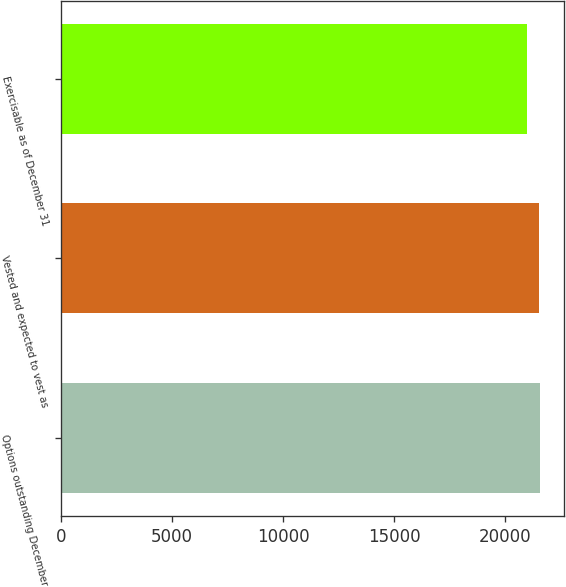Convert chart. <chart><loc_0><loc_0><loc_500><loc_500><bar_chart><fcel>Options outstanding December<fcel>Vested and expected to vest as<fcel>Exercisable as of December 31<nl><fcel>21543<fcel>21492<fcel>20986<nl></chart> 